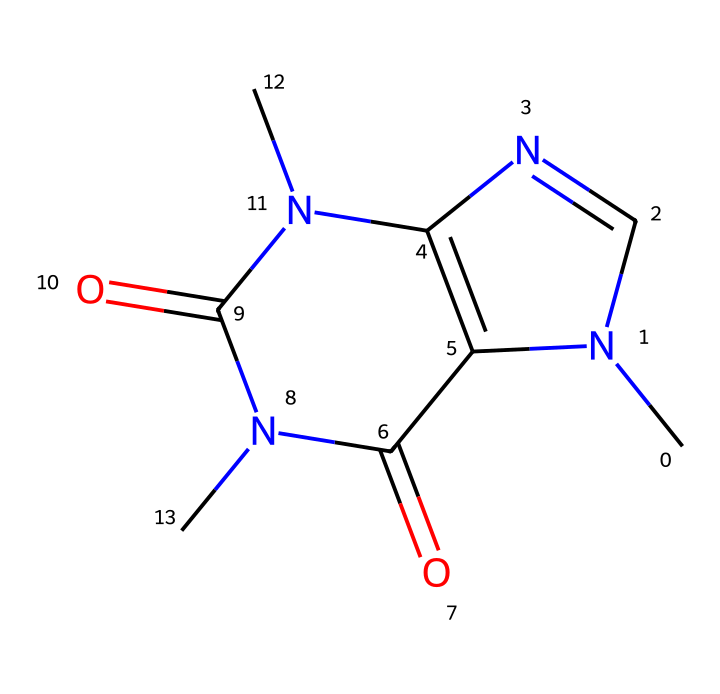What is the molecular formula of caffeine? To determine the molecular formula from the SMILES representation, count the number of each atom type (C, H, N, O). The structure includes 8 carbons, 10 hydrogens, 4 nitrogens, and 2 oxygens. Thus, the molecular formula is C8H10N4O2.
Answer: C8H10N4O2 How many nitrogen atoms are present in caffeine? By analyzing the structure or counting the N's in the SMILES, we see there are four nitrogen atoms in the chemical structure of caffeine.
Answer: 4 What type of compound is caffeine? Caffeine is an alkaloid, which is a class of nitrogen-containing compounds commonly found in plants and known for their physiological effects. The presence of nitrogen atoms and the structure indicates it is an alkaloid.
Answer: alkaloid What is the molecular weight of caffeine? The molecular weight can be determined by summing the atomic weights of all atoms in the molecular formula C8H10N4O2: (8*12.01g/mol for C) + (10*1.008g/mol for H) + (4*14.01g/mol for N) + (2*16.00g/mol for O), which equals about 194.19 g/mol.
Answer: 194.19 g/mol Which part of the structure contributes to caffeine's stimulant effect? The nitrogen atoms in the structure are crucial, as they are part of the chemical's interactions with neurotransmitter receptors like adenosine, which governs the stimulant effect.
Answer: nitrogen atoms Is caffeine a saturated or unsaturated compound? By examining the structure, we can see that caffeine contains double bonds (noted in the SMILES), indicating that it is unsaturated. Therefore, caffeine is classified as an unsaturated compound.
Answer: unsaturated 